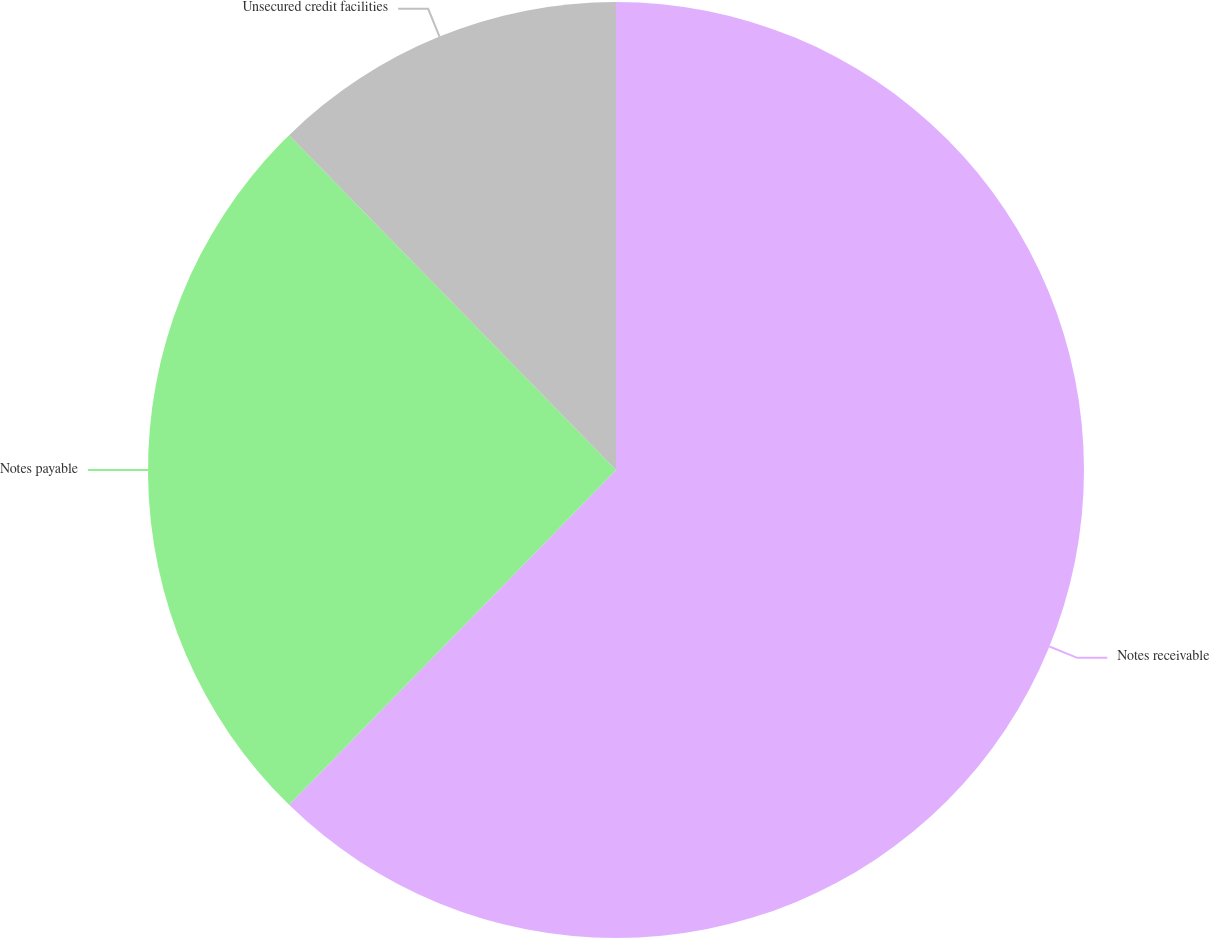<chart> <loc_0><loc_0><loc_500><loc_500><pie_chart><fcel>Notes receivable<fcel>Notes payable<fcel>Unsecured credit facilities<nl><fcel>62.31%<fcel>25.38%<fcel>12.31%<nl></chart> 